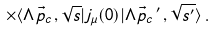<formula> <loc_0><loc_0><loc_500><loc_500>\times \langle \Lambda \vec { p } _ { c } \, , \sqrt { s } | j _ { \mu } ( 0 ) | \Lambda \vec { p } _ { c } \, ^ { \prime } \, , \sqrt { s ^ { \prime } } \rangle \, .</formula> 